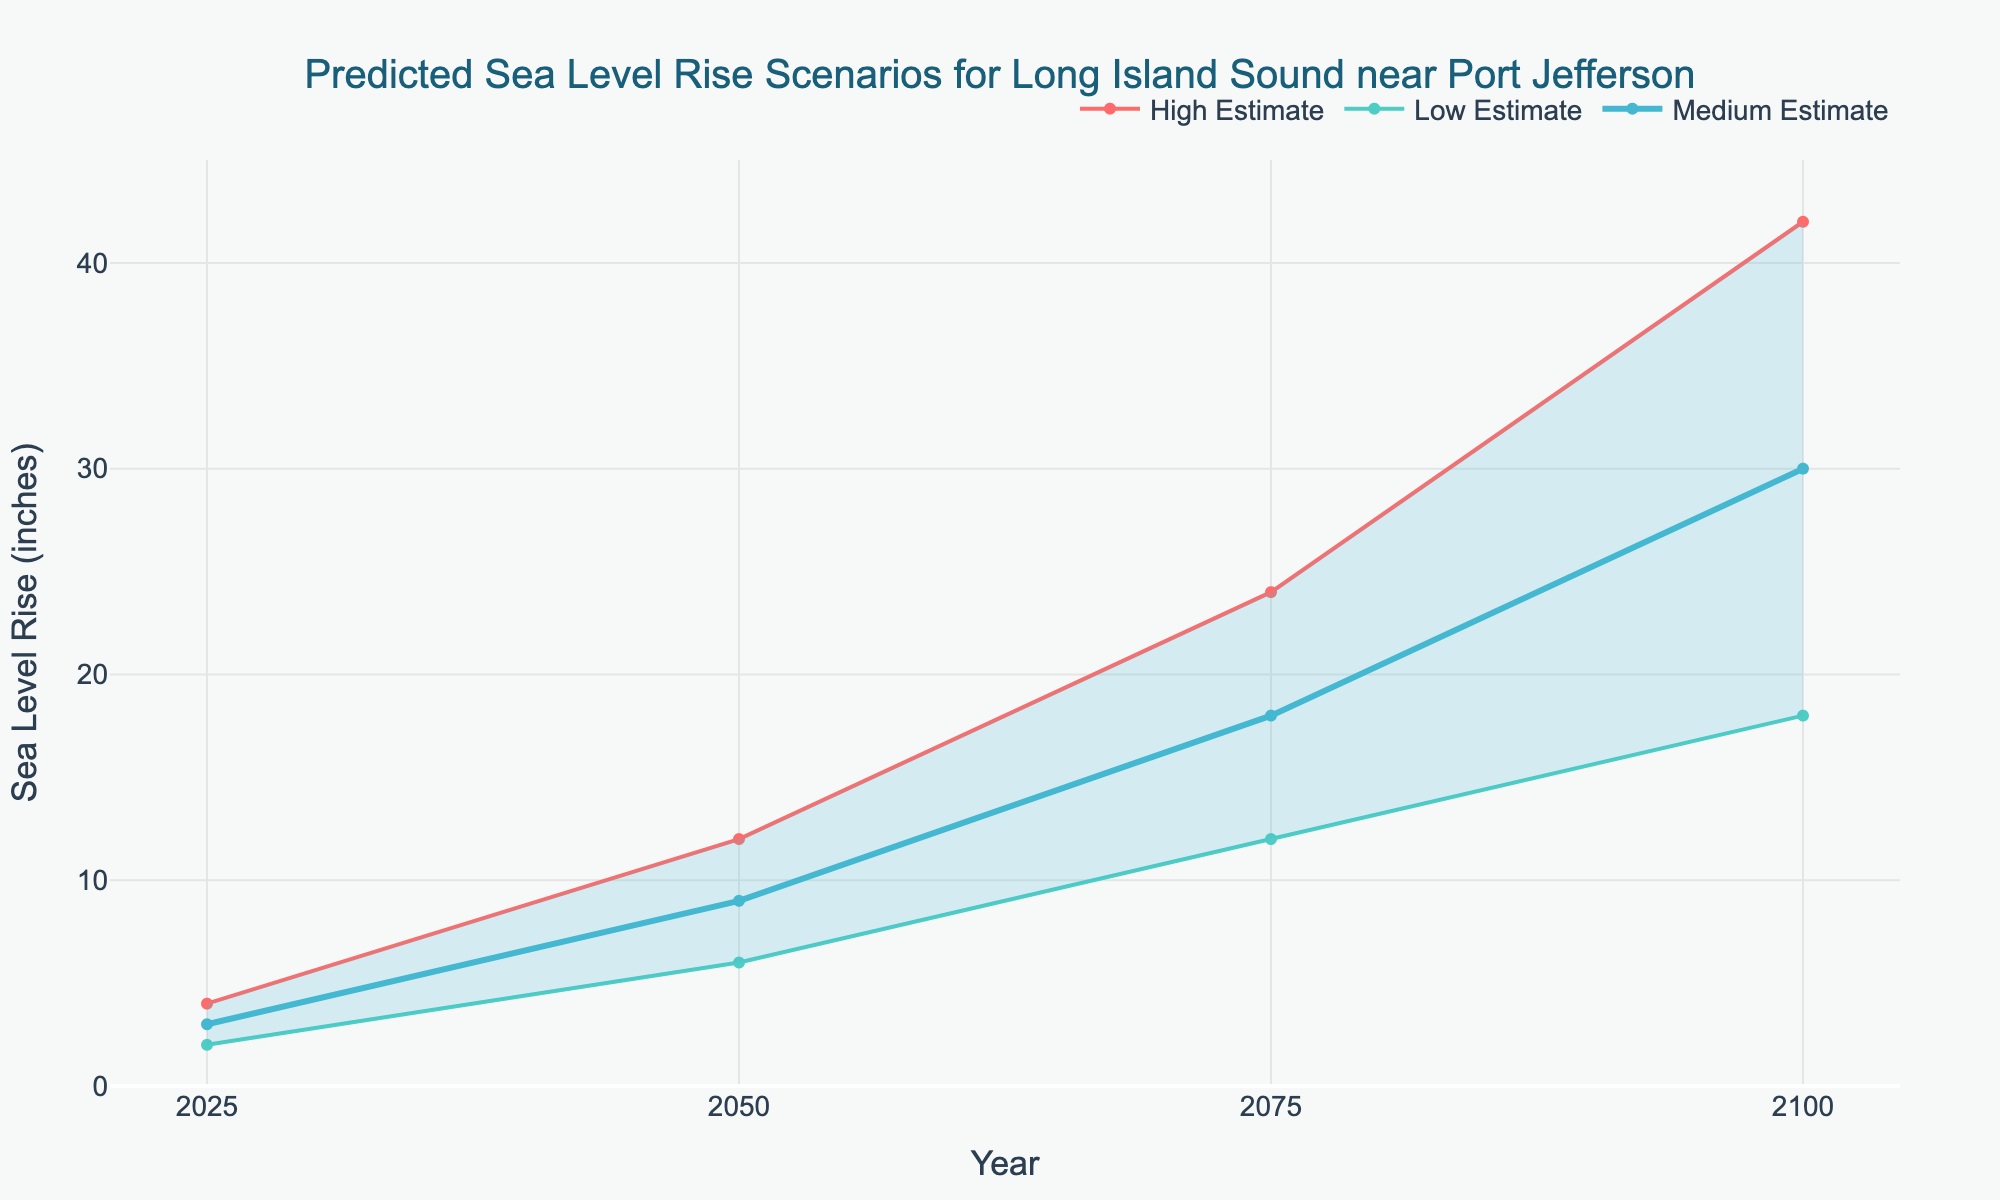What is the title of the figure? The title is positioned at the top and is meant to describe the content of the figure.
Answer: Predicted Sea Level Rise Scenarios for Long Island Sound near Port Jefferson What are the sea level rise estimations for the year 2050? The estimations for sea level rise in 2050 can be found by locating the year 2050 on the x-axis and referring to the corresponding data points for Low, Medium, and High estimates.
Answer: 6, 9, 12 inches In what year is the Medium Estimate expected to be 30 inches? Locate the Medium Estimate line and find the year when it reaches the 30-inch level on the y-axis.
Answer: 2100 Which estimate line is given the thickest visual representation? Observing the thickness of the lines representing each estimate will reveal that one is notably thicker.
Answer: Medium Estimate How much higher is the High Estimate compared to the Low Estimate in 2100? Subtract the Low Estimate for 2100 from the High Estimate for 2100 to find the difference.
Answer: 24 inches What is the range of the sea level rise in 2025 across all estimates? Identify and subtract the Low Estimate for 2025 from the High Estimate for 2025 to find the range.
Answer: 2 inches Does the gap between High and Low estimates increase, decrease, or stay the same over time? Observe the spacing between the High and Low estimate lines from 2025 to 2100 to determine the trend over time.
Answer: Increase By how many inches does the Medium Estimate increase from 2025 to 2075? Find the Medium Estimate values for 2025 and 2075, and subtract the 2025 value from the 2075 value to determine the increase.
Answer: 15 inches Which year shows the highest overall predicted sea level rise? Determine the year with the highest value on the y-axis by examining the High Estimate line.
Answer: 2100 